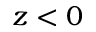<formula> <loc_0><loc_0><loc_500><loc_500>z < 0</formula> 